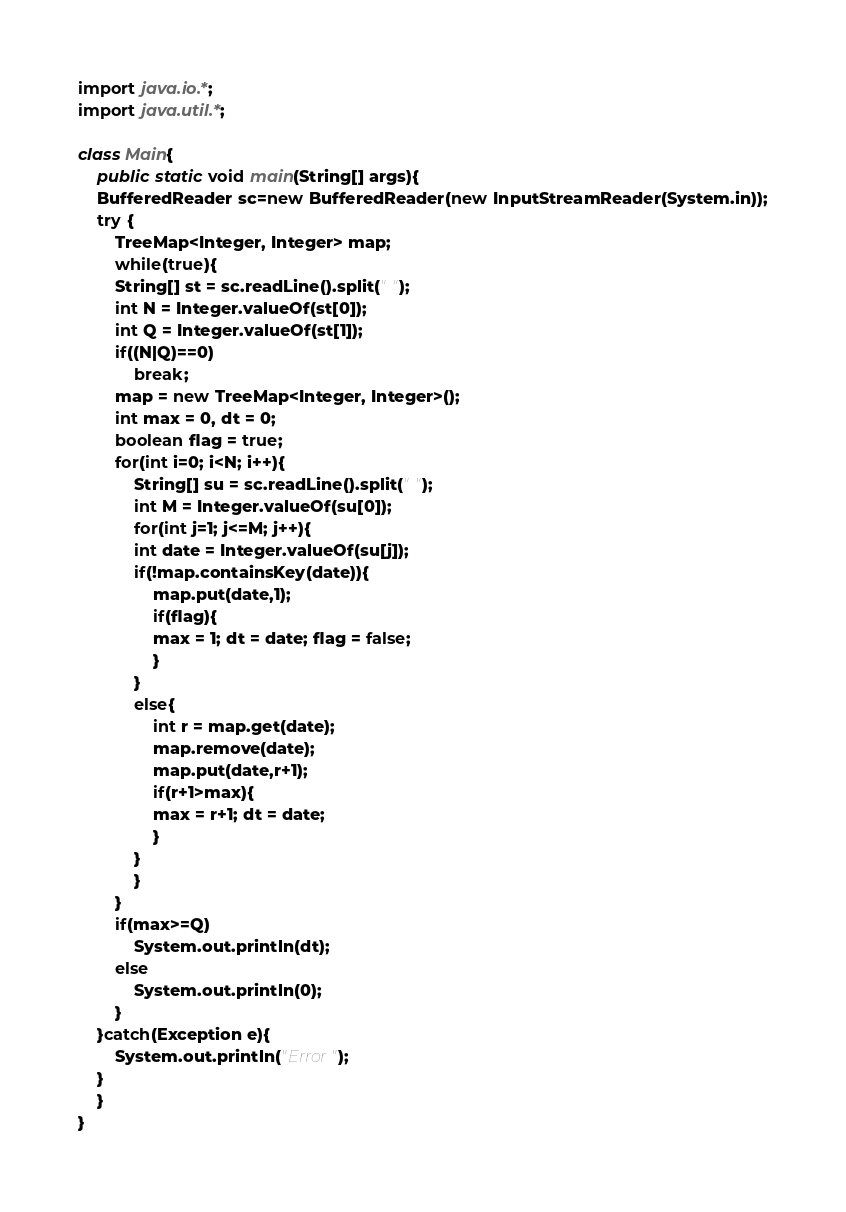Convert code to text. <code><loc_0><loc_0><loc_500><loc_500><_Java_>import java.io.*;
import java.util.*;

class Main{
    public static void main(String[] args){
	BufferedReader sc=new BufferedReader(new InputStreamReader(System.in));
	try {
	    TreeMap<Integer, Integer> map;
	    while(true){
		String[] st = sc.readLine().split(" ");
		int N = Integer.valueOf(st[0]);
		int Q = Integer.valueOf(st[1]);
		if((N|Q)==0)
		    break;
		map = new TreeMap<Integer, Integer>();
		int max = 0, dt = 0;
		boolean flag = true;
		for(int i=0; i<N; i++){
		    String[] su = sc.readLine().split(" ");
		    int M = Integer.valueOf(su[0]);
		    for(int j=1; j<=M; j++){
			int date = Integer.valueOf(su[j]);
			if(!map.containsKey(date)){
			    map.put(date,1);
			    if(flag){
				max = 1; dt = date; flag = false;
			    }
			}
			else{
			    int r = map.get(date);
			    map.remove(date);
			    map.put(date,r+1);
			    if(r+1>max){
				max = r+1; dt = date;
			    }
			}
		    }
		}
		if(max>=Q)
		    System.out.println(dt);
		else
		    System.out.println(0);
	    }
	}catch(Exception e){
	    System.out.println("Error");
	}
    }
}</code> 